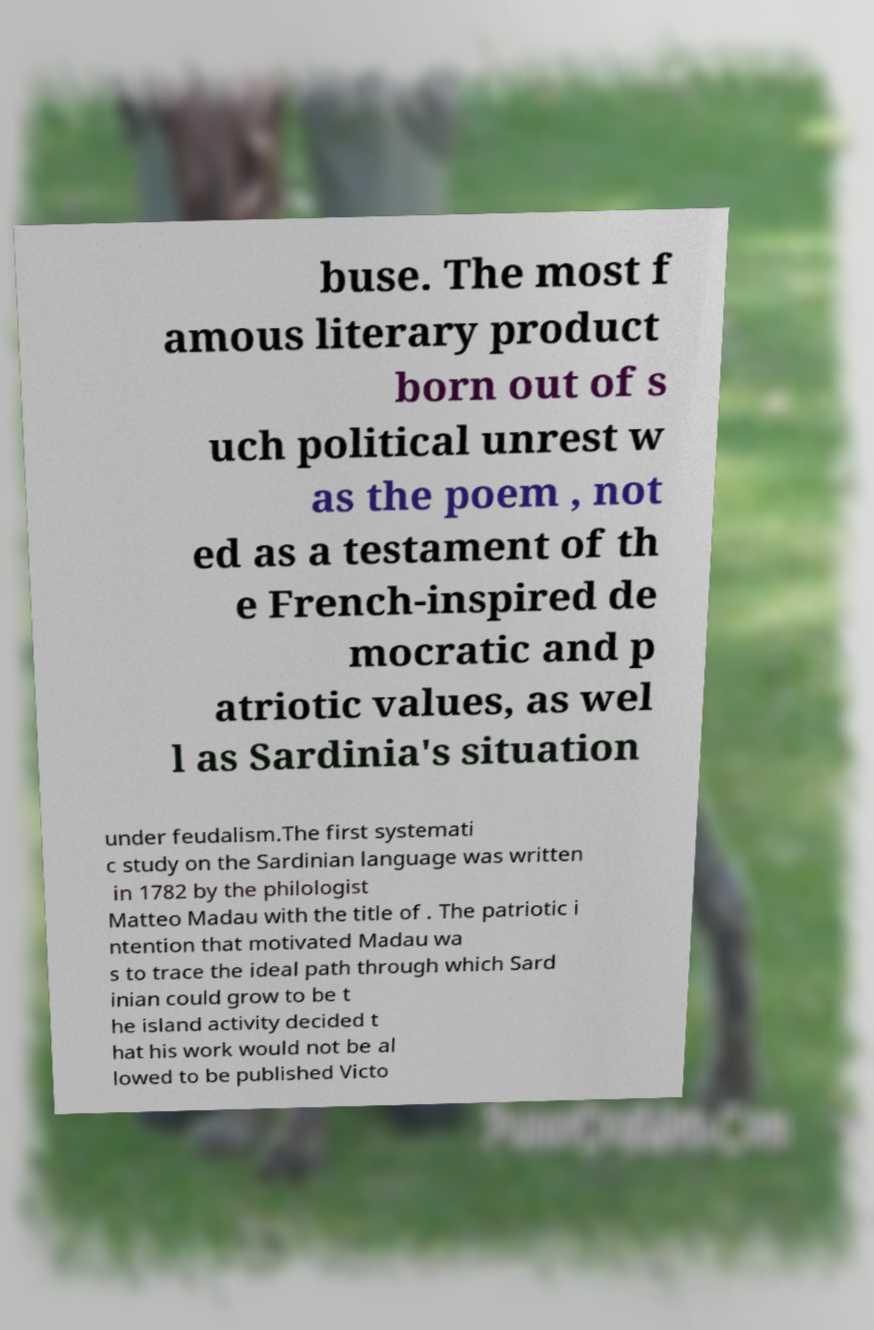Please read and relay the text visible in this image. What does it say? buse. The most f amous literary product born out of s uch political unrest w as the poem , not ed as a testament of th e French-inspired de mocratic and p atriotic values, as wel l as Sardinia's situation under feudalism.The first systemati c study on the Sardinian language was written in 1782 by the philologist Matteo Madau with the title of . The patriotic i ntention that motivated Madau wa s to trace the ideal path through which Sard inian could grow to be t he island activity decided t hat his work would not be al lowed to be published Victo 